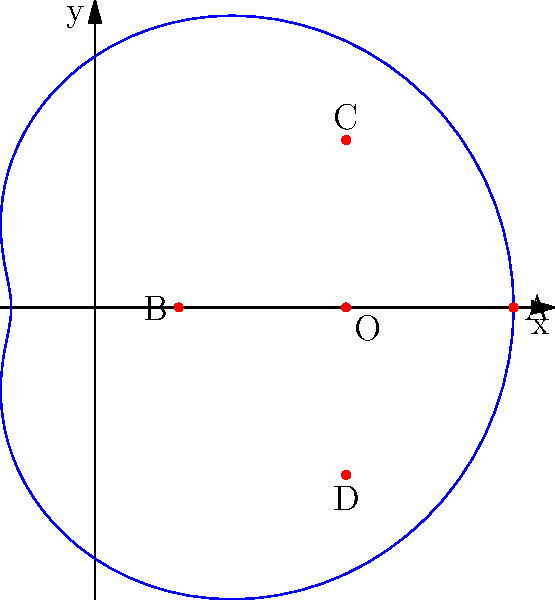As a pharmaceutical company representative, you're tasked with determining the optimal location for a new awareness campaign headquarters. The potential locations are represented in polar coordinates on the given graph, where the curve is defined by $r = 3 + 2\cos(\theta)$. Points A, B, C, and D represent possible locations, while O is the current office. Which location would be best suited for the new headquarters if you want to maximize coverage area while maintaining proximity to the current office? To solve this problem, let's analyze each point:

1. First, identify the coordinates of each point:
   O: $(3, 0)$ - Current office
   A: $(5, 0)$ - On the positive x-axis
   B: $(1, 0)$ - On the negative x-axis
   C: $(3, 2)$ - Above the origin
   D: $(3, -2)$ - Below the origin

2. Calculate the distance from each point to the current office (O):
   A to O: $\sqrt{(5-3)^2 + (0-0)^2} = 2$
   B to O: $\sqrt{(1-3)^2 + (0-0)^2} = 2$
   C to O: $\sqrt{(3-3)^2 + (2-0)^2} = 2$
   D to O: $\sqrt{(3-3)^2 + (-2-0)^2} = 2$

3. Consider the coverage area:
   - Points A and B are on the x-axis, providing limited directional coverage.
   - Points C and D are equidistant from O but in opposite directions (north and south).
   
4. Evaluate the strategic positioning:
   - Point C (north) is likely to provide better visibility and accessibility for awareness campaigns.
   - Being above the current office, it may symbolize growth and progress.

5. Consider the polar equation $r = 3 + 2\cos(\theta)$:
   - This curve represents the boundary of the optimal coverage area.
   - Point C lies on this curve, indicating it's at the ideal distance for balancing coverage and proximity.

Given these factors, point C $(3, 2)$ would be the best location for the new headquarters. It maintains the same distance from the current office as other options while providing a strategic position for visibility and symbolizing growth.
Answer: Point C $(3, 2)$ 